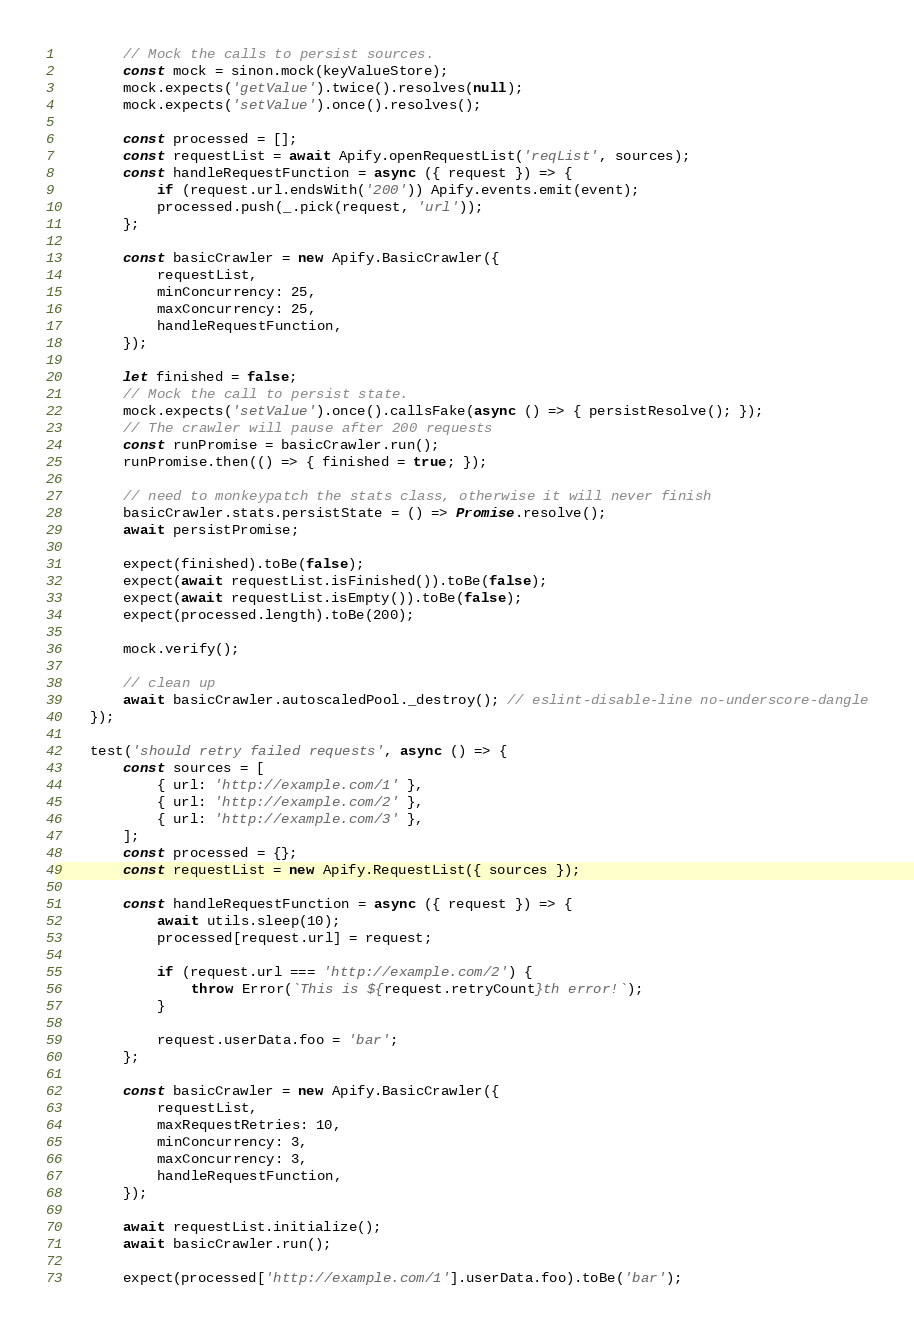<code> <loc_0><loc_0><loc_500><loc_500><_JavaScript_>
        // Mock the calls to persist sources.
        const mock = sinon.mock(keyValueStore);
        mock.expects('getValue').twice().resolves(null);
        mock.expects('setValue').once().resolves();

        const processed = [];
        const requestList = await Apify.openRequestList('reqList', sources);
        const handleRequestFunction = async ({ request }) => {
            if (request.url.endsWith('200')) Apify.events.emit(event);
            processed.push(_.pick(request, 'url'));
        };

        const basicCrawler = new Apify.BasicCrawler({
            requestList,
            minConcurrency: 25,
            maxConcurrency: 25,
            handleRequestFunction,
        });

        let finished = false;
        // Mock the call to persist state.
        mock.expects('setValue').once().callsFake(async () => { persistResolve(); });
        // The crawler will pause after 200 requests
        const runPromise = basicCrawler.run();
        runPromise.then(() => { finished = true; });

        // need to monkeypatch the stats class, otherwise it will never finish
        basicCrawler.stats.persistState = () => Promise.resolve();
        await persistPromise;

        expect(finished).toBe(false);
        expect(await requestList.isFinished()).toBe(false);
        expect(await requestList.isEmpty()).toBe(false);
        expect(processed.length).toBe(200);

        mock.verify();

        // clean up
        await basicCrawler.autoscaledPool._destroy(); // eslint-disable-line no-underscore-dangle
    });

    test('should retry failed requests', async () => {
        const sources = [
            { url: 'http://example.com/1' },
            { url: 'http://example.com/2' },
            { url: 'http://example.com/3' },
        ];
        const processed = {};
        const requestList = new Apify.RequestList({ sources });

        const handleRequestFunction = async ({ request }) => {
            await utils.sleep(10);
            processed[request.url] = request;

            if (request.url === 'http://example.com/2') {
                throw Error(`This is ${request.retryCount}th error!`);
            }

            request.userData.foo = 'bar';
        };

        const basicCrawler = new Apify.BasicCrawler({
            requestList,
            maxRequestRetries: 10,
            minConcurrency: 3,
            maxConcurrency: 3,
            handleRequestFunction,
        });

        await requestList.initialize();
        await basicCrawler.run();

        expect(processed['http://example.com/1'].userData.foo).toBe('bar');</code> 